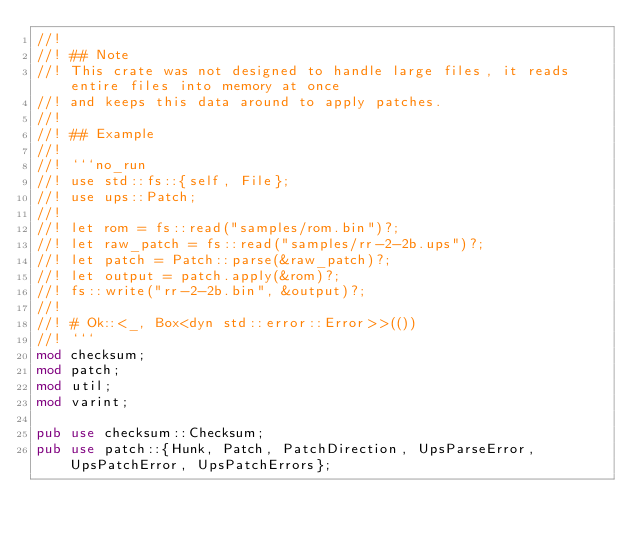Convert code to text. <code><loc_0><loc_0><loc_500><loc_500><_Rust_>//!
//! ## Note
//! This crate was not designed to handle large files, it reads entire files into memory at once
//! and keeps this data around to apply patches.
//!
//! ## Example
//!
//! ```no_run
//! use std::fs::{self, File};
//! use ups::Patch;
//!
//! let rom = fs::read("samples/rom.bin")?;
//! let raw_patch = fs::read("samples/rr-2-2b.ups")?;
//! let patch = Patch::parse(&raw_patch)?;
//! let output = patch.apply(&rom)?;
//! fs::write("rr-2-2b.bin", &output)?;
//!
//! # Ok::<_, Box<dyn std::error::Error>>(())
//! ```
mod checksum;
mod patch;
mod util;
mod varint;

pub use checksum::Checksum;
pub use patch::{Hunk, Patch, PatchDirection, UpsParseError, UpsPatchError, UpsPatchErrors};
</code> 